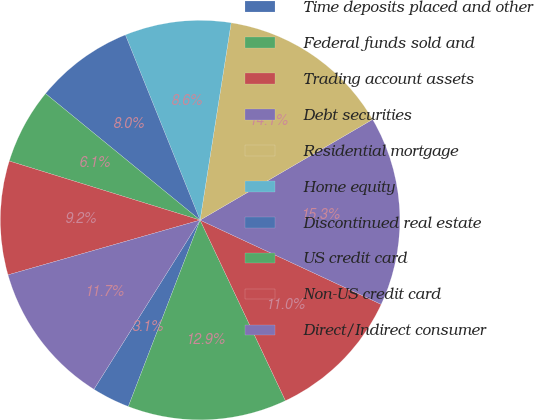Convert chart to OTSL. <chart><loc_0><loc_0><loc_500><loc_500><pie_chart><fcel>Time deposits placed and other<fcel>Federal funds sold and<fcel>Trading account assets<fcel>Debt securities<fcel>Residential mortgage<fcel>Home equity<fcel>Discontinued real estate<fcel>US credit card<fcel>Non-US credit card<fcel>Direct/Indirect consumer<nl><fcel>3.07%<fcel>12.88%<fcel>11.04%<fcel>15.34%<fcel>14.11%<fcel>8.59%<fcel>7.98%<fcel>6.14%<fcel>9.2%<fcel>11.66%<nl></chart> 